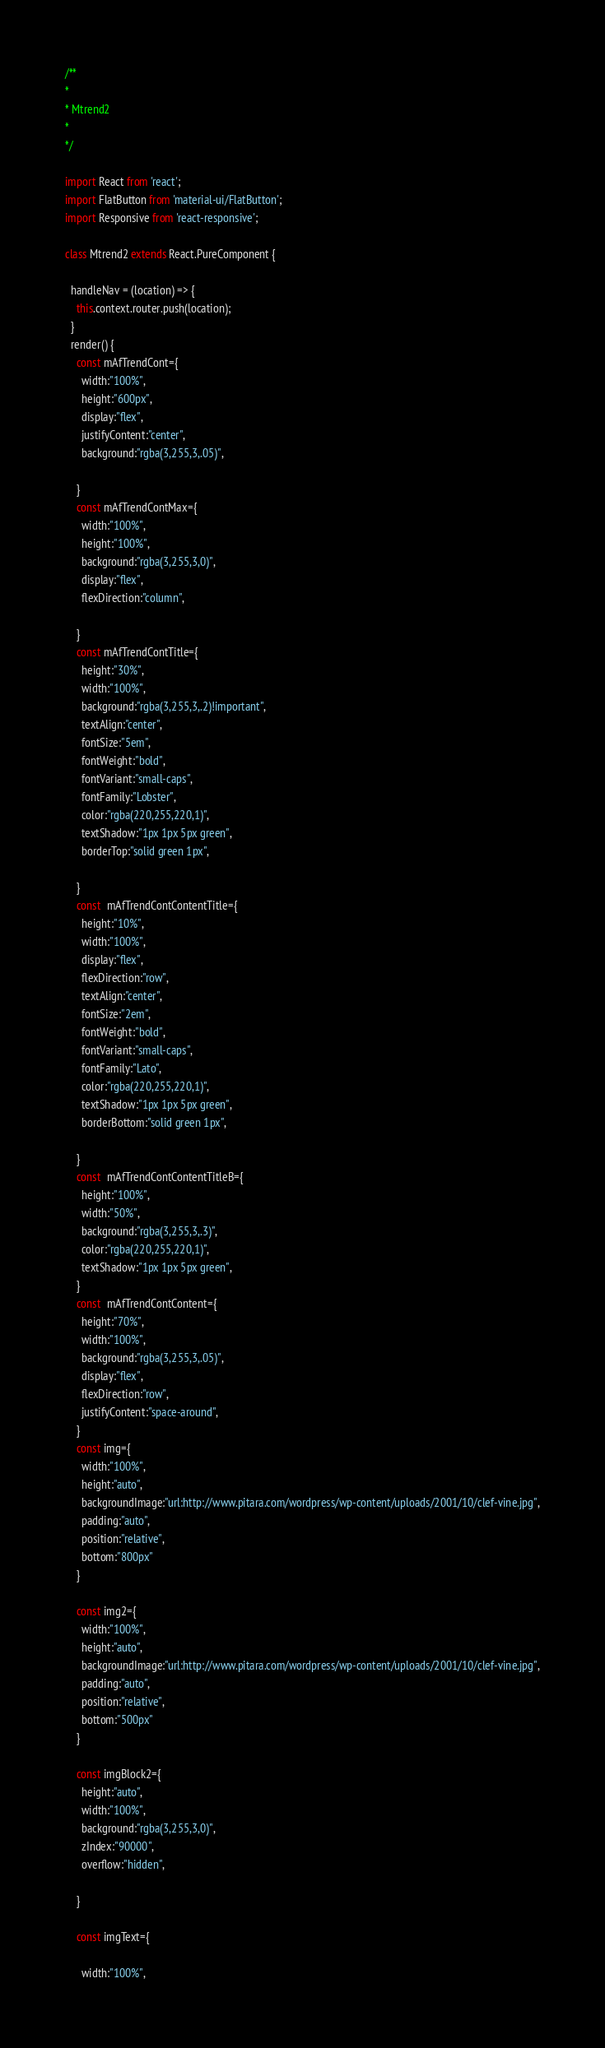Convert code to text. <code><loc_0><loc_0><loc_500><loc_500><_JavaScript_>/**
*
* Mtrend2
*
*/

import React from 'react';
import FlatButton from 'material-ui/FlatButton';
import Responsive from 'react-responsive';

class Mtrend2 extends React.PureComponent {

  handleNav = (location) => {
    this.context.router.push(location);
  }
  render() {
    const mAfTrendCont={
      width:"100%",
      height:"600px",
      display:"flex",
      justifyContent:"center",
      background:"rgba(3,255,3,.05)",

    }
    const mAfTrendContMax={
      width:"100%",
      height:"100%",
      background:"rgba(3,255,3,0)",
      display:"flex",
      flexDirection:"column",

    }
    const mAfTrendContTitle={
      height:"30%",
      width:"100%",
      background:"rgba(3,255,3,.2)!important",
      textAlign:"center",
      fontSize:"5em",
      fontWeight:"bold",
      fontVariant:"small-caps",
      fontFamily:"Lobster",
      color:"rgba(220,255,220,1)",
      textShadow:"1px 1px 5px green",
      borderTop:"solid green 1px",

    }
    const  mAfTrendContContentTitle={
      height:"10%",
      width:"100%",
      display:"flex",
      flexDirection:"row",
      textAlign:"center",
      fontSize:"2em",
      fontWeight:"bold",
      fontVariant:"small-caps",
      fontFamily:"Lato",
      color:"rgba(220,255,220,1)",
      textShadow:"1px 1px 5px green",
      borderBottom:"solid green 1px",

    }
    const  mAfTrendContContentTitleB={
      height:"100%",
      width:"50%",
      background:"rgba(3,255,3,.3)",
      color:"rgba(220,255,220,1)",
      textShadow:"1px 1px 5px green",
    }
    const  mAfTrendContContent={
      height:"70%",
      width:"100%",
      background:"rgba(3,255,3,.05)",
      display:"flex",
      flexDirection:"row",
      justifyContent:"space-around",
    }
    const img={
      width:"100%",
      height:"auto",
      backgroundImage:"url:http://www.pitara.com/wordpress/wp-content/uploads/2001/10/clef-vine.jpg",
      padding:"auto",
      position:"relative",
      bottom:"800px"
    }

    const img2={
      width:"100%",
      height:"auto",
      backgroundImage:"url:http://www.pitara.com/wordpress/wp-content/uploads/2001/10/clef-vine.jpg",
      padding:"auto",
      position:"relative",
      bottom:"500px"
    }

    const imgBlock2={
      height:"auto",
      width:"100%",
      background:"rgba(3,255,3,0)",
      zIndex:"90000",
      overflow:"hidden",

    }

    const imgText={

      width:"100%",</code> 